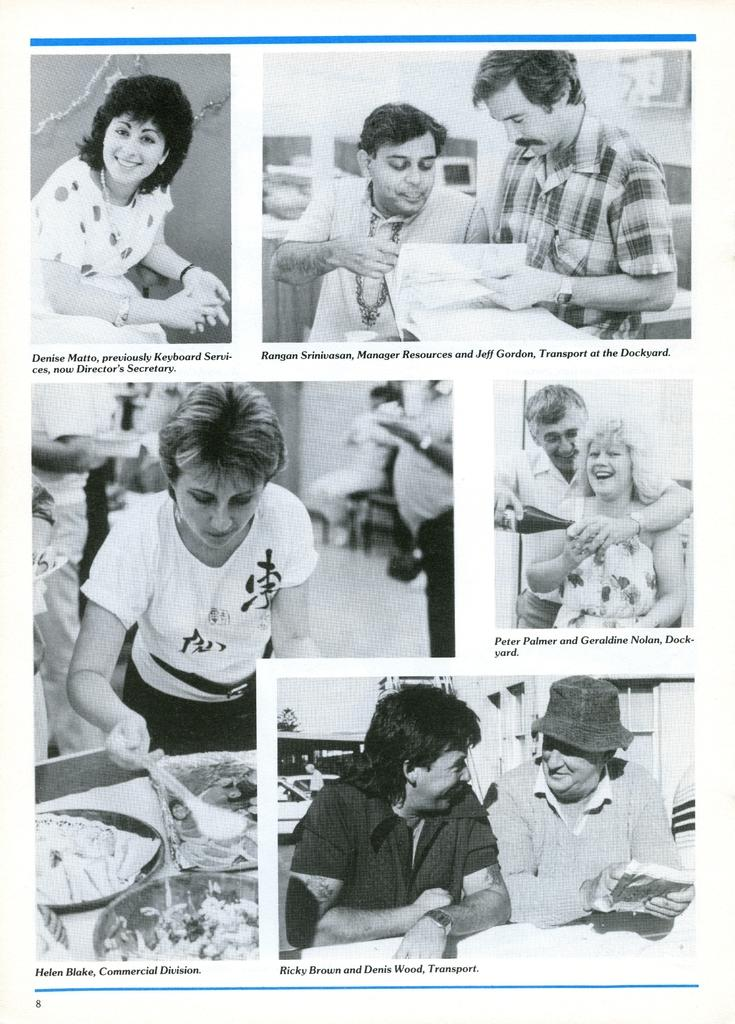What is the color scheme of the image? The image is black and white. What type of image is it? The image is a collage of different people. Are there any labels or descriptions in the image? Yes, there is text written under each image. What type of frame is around the coast in the image? There is no frame or coast present in the image; it is a black and white collage of different people with text underneath each image. 